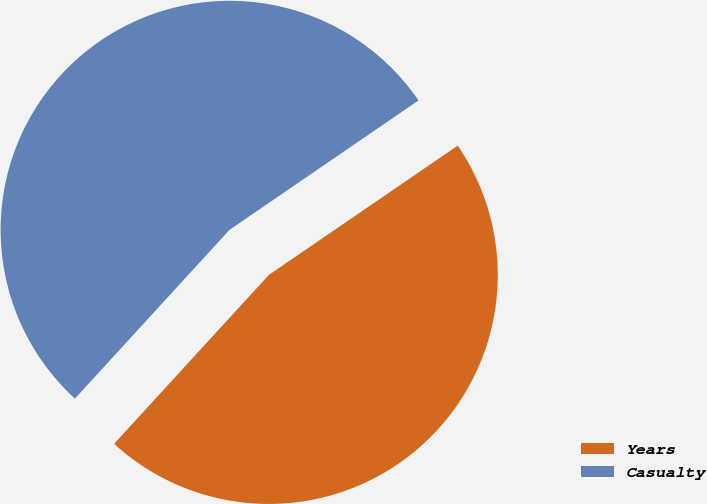<chart> <loc_0><loc_0><loc_500><loc_500><pie_chart><fcel>Years<fcel>Casualty<nl><fcel>46.36%<fcel>53.64%<nl></chart> 